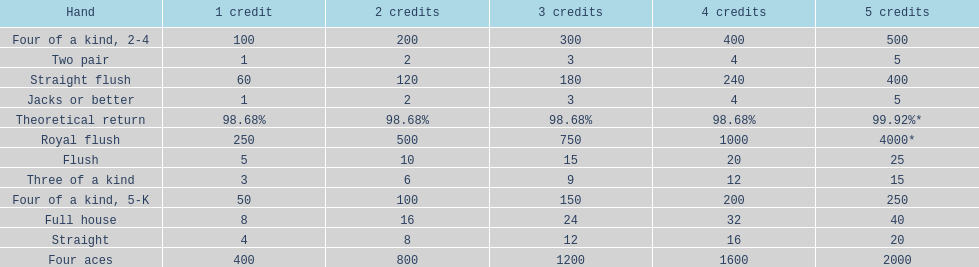Could you parse the entire table? {'header': ['Hand', '1 credit', '2 credits', '3 credits', '4 credits', '5 credits'], 'rows': [['Four of a kind, 2-4', '100', '200', '300', '400', '500'], ['Two pair', '1', '2', '3', '4', '5'], ['Straight flush', '60', '120', '180', '240', '400'], ['Jacks or better', '1', '2', '3', '4', '5'], ['Theoretical return', '98.68%', '98.68%', '98.68%', '98.68%', '99.92%*'], ['Royal flush', '250', '500', '750', '1000', '4000*'], ['Flush', '5', '10', '15', '20', '25'], ['Three of a kind', '3', '6', '9', '12', '15'], ['Four of a kind, 5-K', '50', '100', '150', '200', '250'], ['Full house', '8', '16', '24', '32', '40'], ['Straight', '4', '8', '12', '16', '20'], ['Four aces', '400', '800', '1200', '1600', '2000']]} At most, what could a person earn for having a full house? 40. 